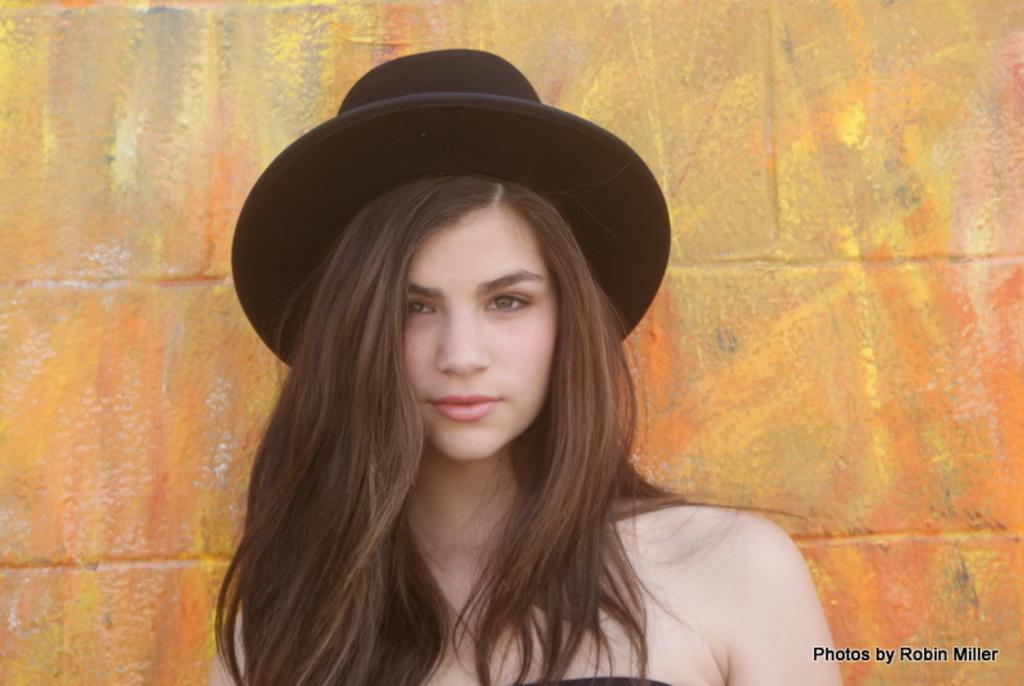What is the main subject of the image? There is a woman standing in the image. What is the woman wearing on her head? The woman is wearing a cap on her head. What can be seen in the background of the image? There is a wall in the background of the image. What is depicted on the wall? The wall has paintings on it. Where is the text located in the image? There is text in the bottom right corner of the image. What type of test is the woman conducting in the image? There is no indication of a test being conducted in the image; the woman is simply standing with a cap on her head. How does the woman express her anger in the image? There is no indication of anger in the image; the woman's expression is not described. 